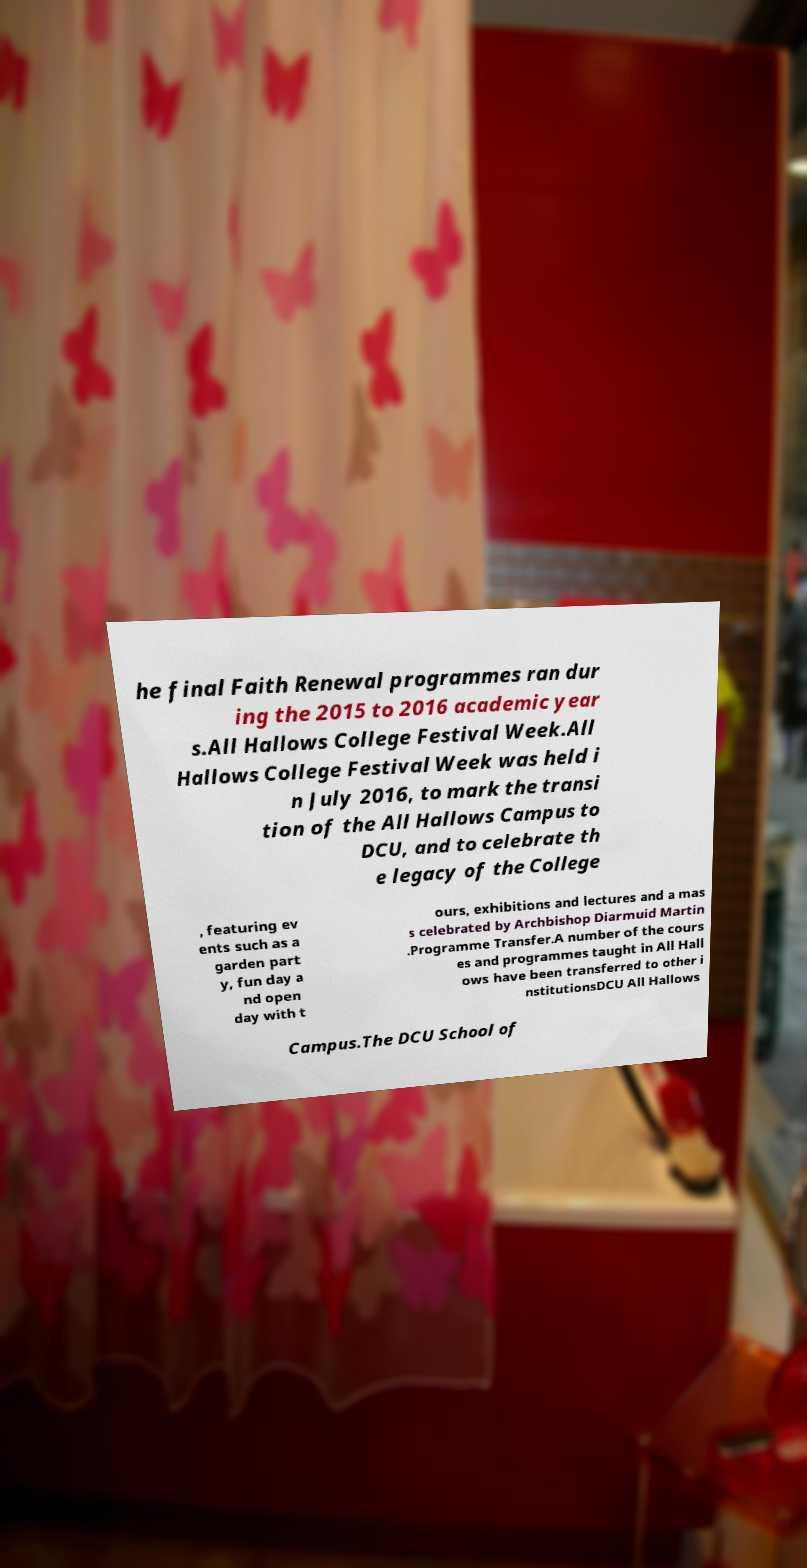I need the written content from this picture converted into text. Can you do that? he final Faith Renewal programmes ran dur ing the 2015 to 2016 academic year s.All Hallows College Festival Week.All Hallows College Festival Week was held i n July 2016, to mark the transi tion of the All Hallows Campus to DCU, and to celebrate th e legacy of the College , featuring ev ents such as a garden part y, fun day a nd open day with t ours, exhibitions and lectures and a mas s celebrated by Archbishop Diarmuid Martin .Programme Transfer.A number of the cours es and programmes taught in All Hall ows have been transferred to other i nstitutionsDCU All Hallows Campus.The DCU School of 